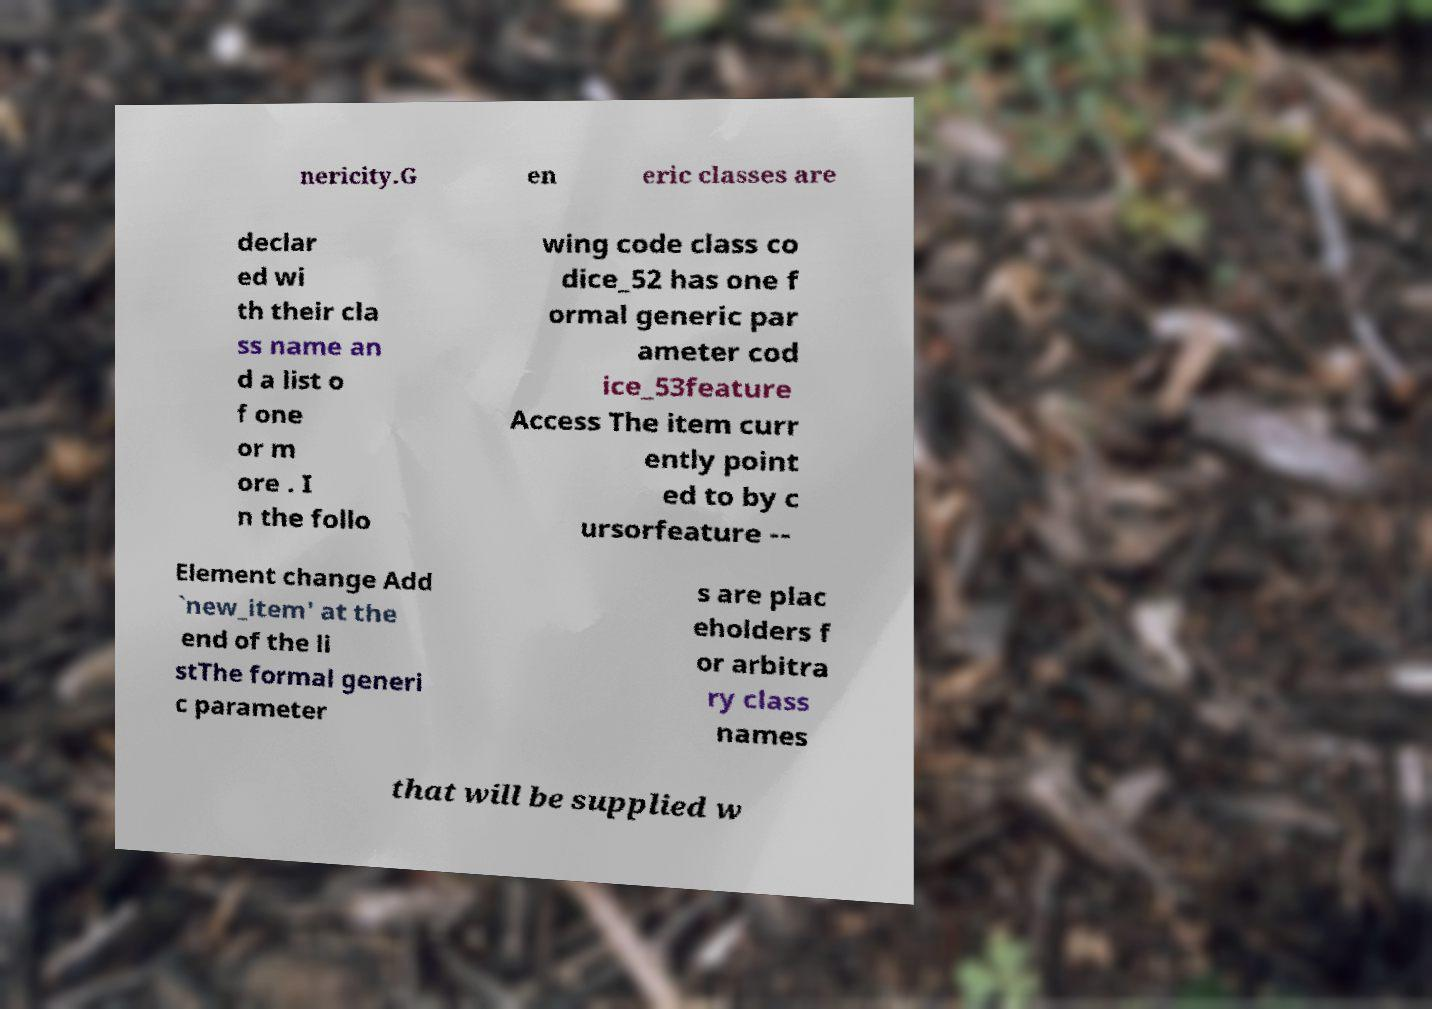Please read and relay the text visible in this image. What does it say? nericity.G en eric classes are declar ed wi th their cla ss name an d a list o f one or m ore . I n the follo wing code class co dice_52 has one f ormal generic par ameter cod ice_53feature Access The item curr ently point ed to by c ursorfeature -- Element change Add `new_item' at the end of the li stThe formal generi c parameter s are plac eholders f or arbitra ry class names that will be supplied w 